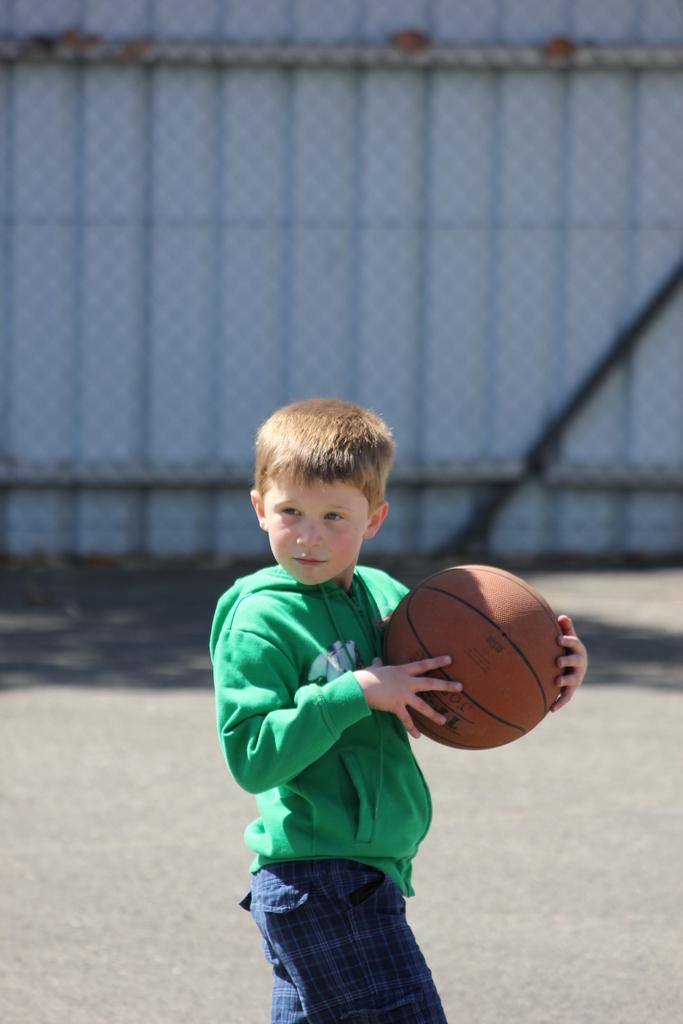What is the main subject of the image? There is a boy in the image. What is the boy doing in the image? The boy is standing in the image. What object is the boy holding in the image? The boy is holding a basketball in the image. What can be seen in the background of the image? There is a background in the image that resembles a door. What type of lipstick is the boy wearing in the image? There is no lipstick or indication of the boy wearing lipstick in the image. 